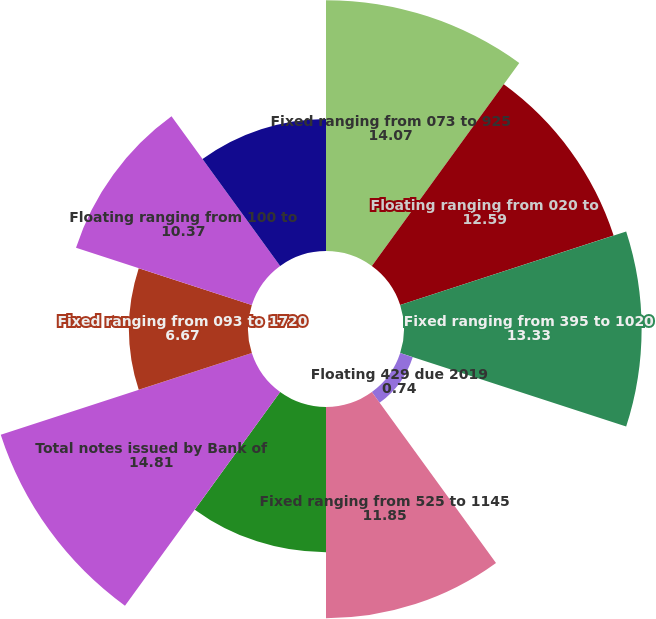Convert chart. <chart><loc_0><loc_0><loc_500><loc_500><pie_chart><fcel>Fixed ranging from 073 to 925<fcel>Floating ranging from 020 to<fcel>Fixed ranging from 395 to 1020<fcel>Floating 429 due 2019<fcel>Fixed ranging from 525 to 1145<fcel>Floating ranging from 487 to<fcel>Total notes issued by Bank of<fcel>Fixed ranging from 093 to 1720<fcel>Floating ranging from 100 to<fcel>Fixed ranging from 575 to 738<nl><fcel>14.07%<fcel>12.59%<fcel>13.33%<fcel>0.74%<fcel>11.85%<fcel>8.15%<fcel>14.81%<fcel>6.67%<fcel>10.37%<fcel>7.41%<nl></chart> 